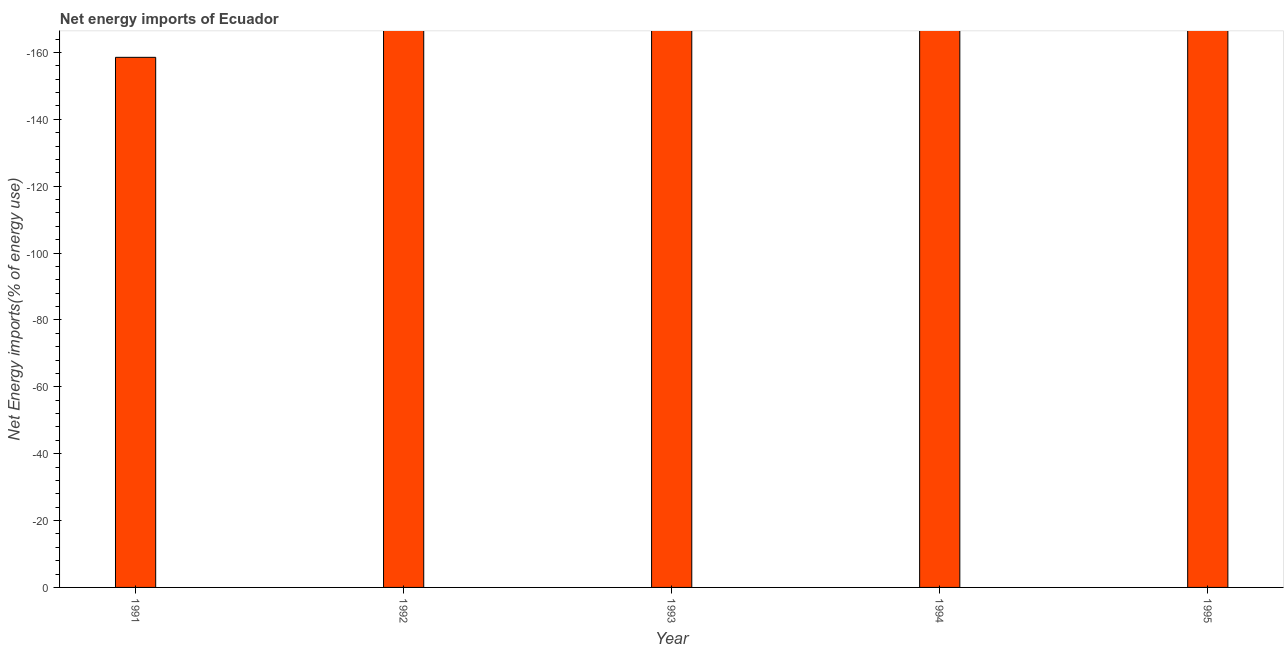Does the graph contain any zero values?
Keep it short and to the point. Yes. What is the title of the graph?
Give a very brief answer. Net energy imports of Ecuador. What is the label or title of the Y-axis?
Offer a terse response. Net Energy imports(% of energy use). Across all years, what is the minimum energy imports?
Your answer should be compact. 0. How many years are there in the graph?
Your answer should be compact. 5. Are the values on the major ticks of Y-axis written in scientific E-notation?
Your answer should be very brief. No. What is the Net Energy imports(% of energy use) of 1991?
Give a very brief answer. 0. What is the Net Energy imports(% of energy use) in 1992?
Your response must be concise. 0. What is the Net Energy imports(% of energy use) in 1993?
Keep it short and to the point. 0. What is the Net Energy imports(% of energy use) of 1995?
Offer a very short reply. 0. 